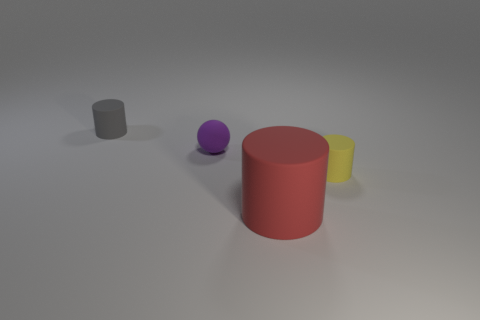Add 1 gray rubber cylinders. How many objects exist? 5 Subtract all large red cylinders. How many cylinders are left? 2 Subtract 1 spheres. How many spheres are left? 0 Subtract all green blocks. How many red cylinders are left? 1 Subtract all small matte objects. Subtract all large objects. How many objects are left? 0 Add 1 large rubber objects. How many large rubber objects are left? 2 Add 1 red matte things. How many red matte things exist? 2 Subtract 0 brown cubes. How many objects are left? 4 Subtract all cylinders. How many objects are left? 1 Subtract all yellow cylinders. Subtract all gray blocks. How many cylinders are left? 2 